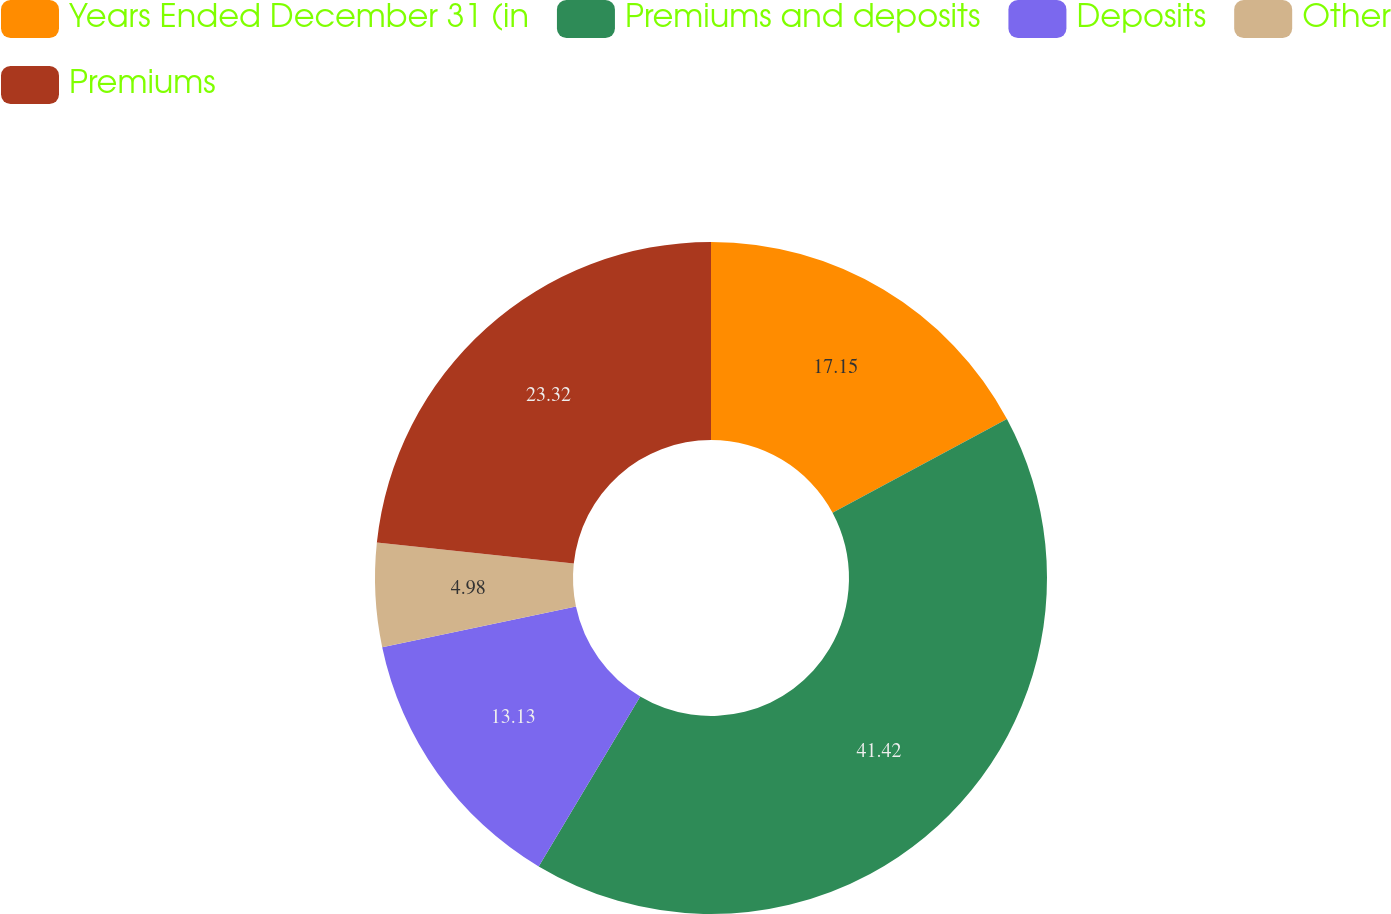Convert chart to OTSL. <chart><loc_0><loc_0><loc_500><loc_500><pie_chart><fcel>Years Ended December 31 (in<fcel>Premiums and deposits<fcel>Deposits<fcel>Other<fcel>Premiums<nl><fcel>17.15%<fcel>41.42%<fcel>13.13%<fcel>4.98%<fcel>23.32%<nl></chart> 